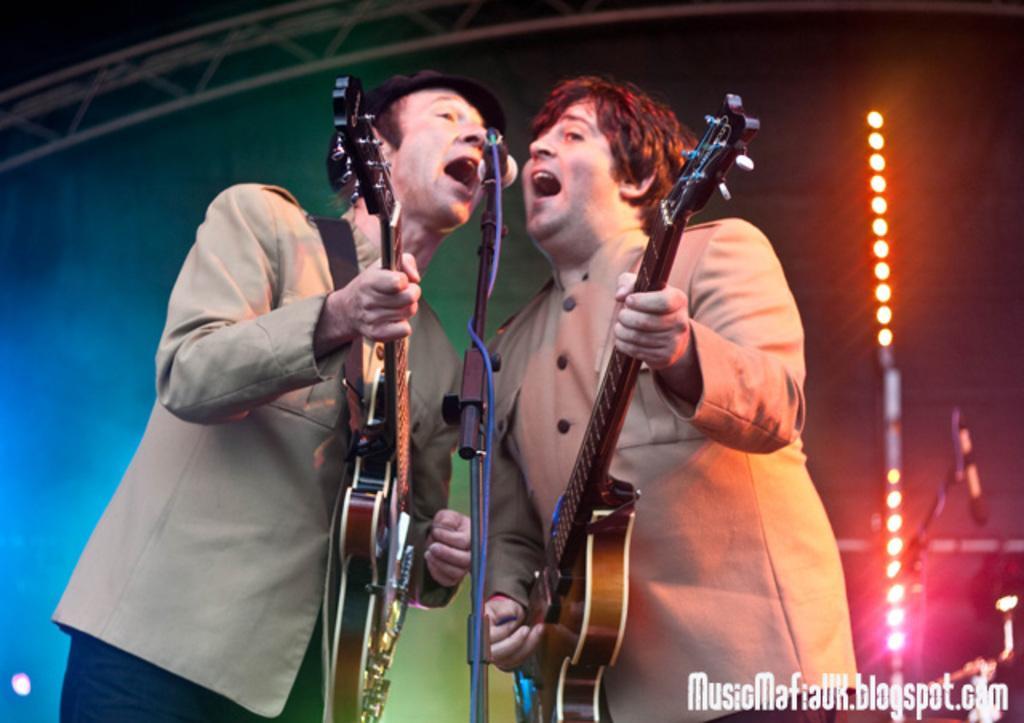Please provide a concise description of this image. In the foreground of the image, there are two persons singing in a mike while holding a guitar in their hands. Both of them are wearing a suit, which is light skin in color. A roof top is made up of metal rod. At the bottom there is a text written. At the right side of the image, there is a focus light. 